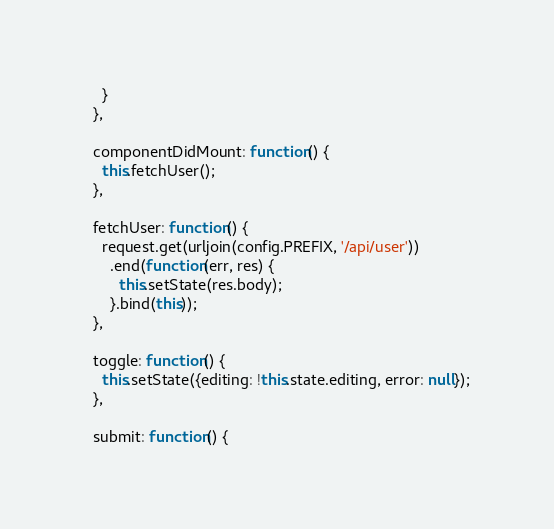Convert code to text. <code><loc_0><loc_0><loc_500><loc_500><_JavaScript_>    }
  },

  componentDidMount: function() {
    this.fetchUser();
  },

  fetchUser: function() {
    request.get(urljoin(config.PREFIX, '/api/user'))
      .end(function(err, res) {
        this.setState(res.body);
      }.bind(this));
  },

  toggle: function() {
    this.setState({editing: !this.state.editing, error: null});
  },

  submit: function() {</code> 